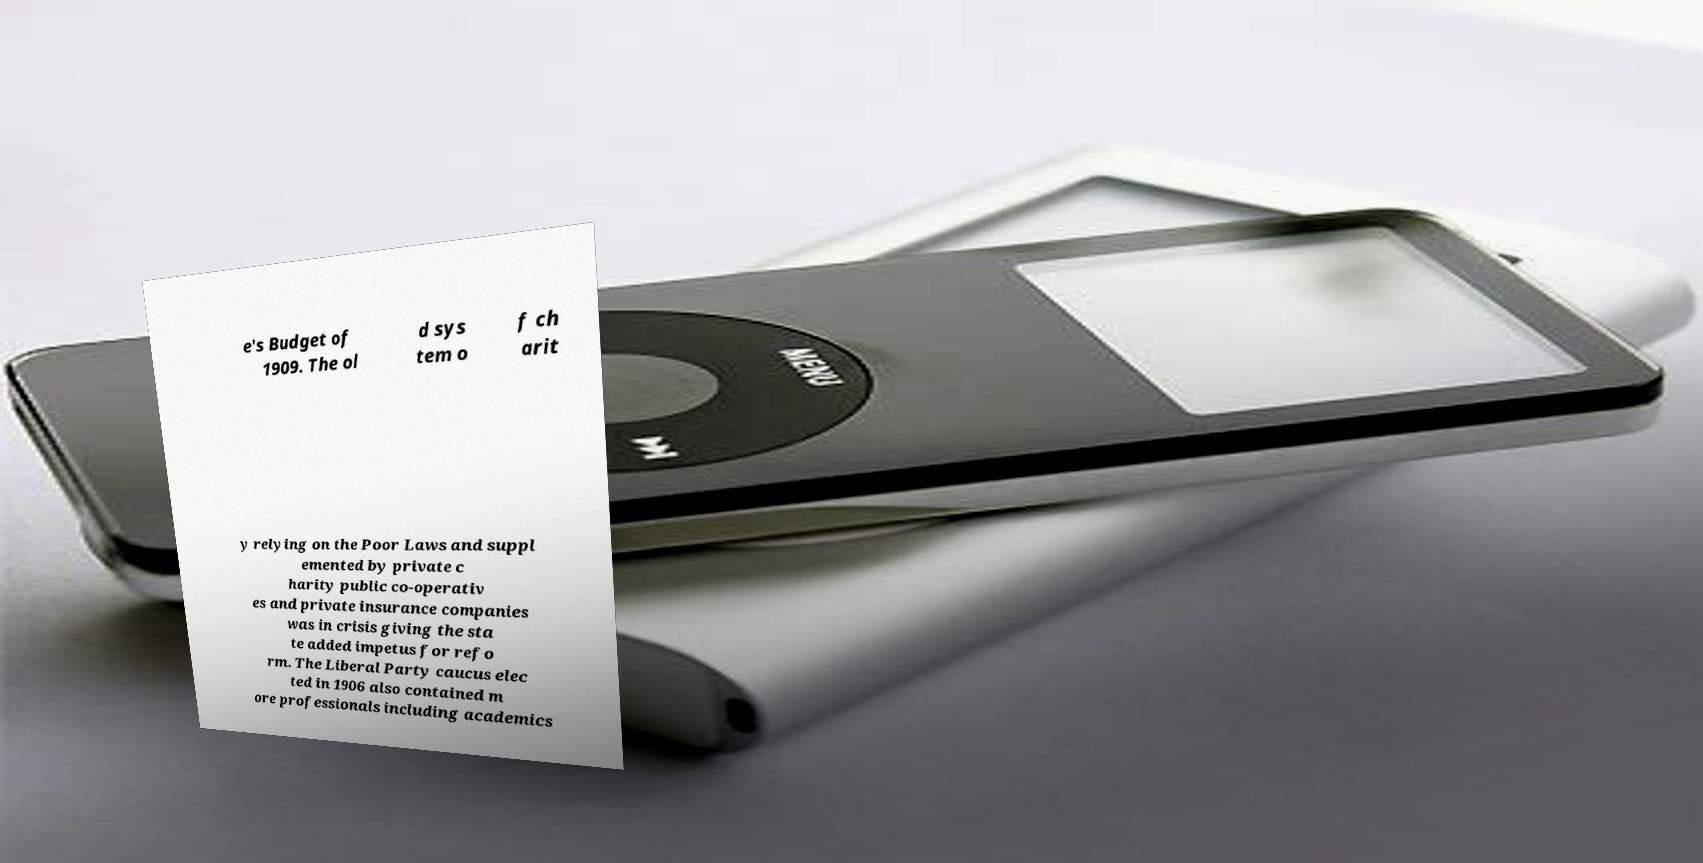Can you read and provide the text displayed in the image?This photo seems to have some interesting text. Can you extract and type it out for me? e's Budget of 1909. The ol d sys tem o f ch arit y relying on the Poor Laws and suppl emented by private c harity public co-operativ es and private insurance companies was in crisis giving the sta te added impetus for refo rm. The Liberal Party caucus elec ted in 1906 also contained m ore professionals including academics 